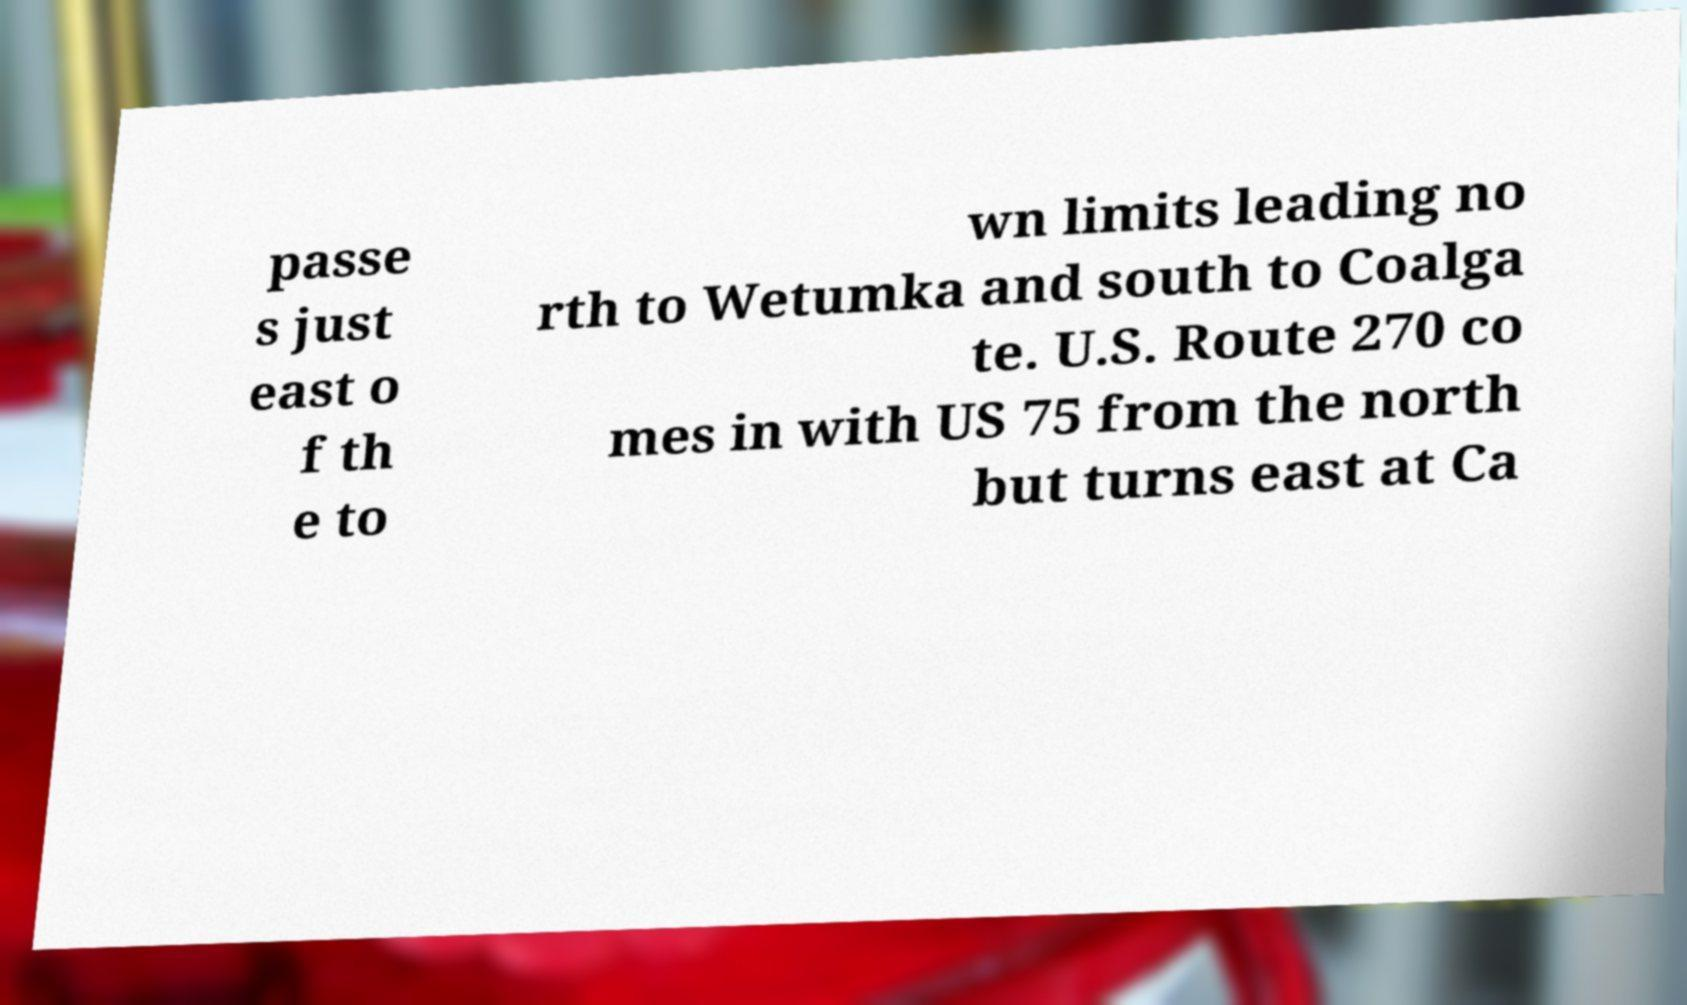There's text embedded in this image that I need extracted. Can you transcribe it verbatim? passe s just east o f th e to wn limits leading no rth to Wetumka and south to Coalga te. U.S. Route 270 co mes in with US 75 from the north but turns east at Ca 